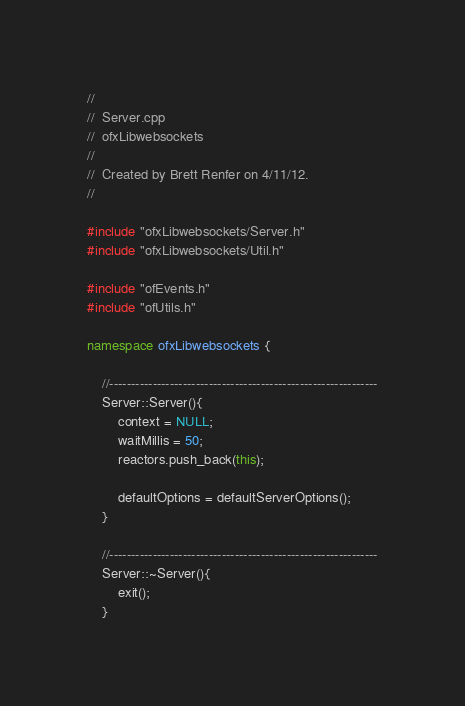Convert code to text. <code><loc_0><loc_0><loc_500><loc_500><_C++_>//
//  Server.cpp
//  ofxLibwebsockets
//
//  Created by Brett Renfer on 4/11/12.
//

#include "ofxLibwebsockets/Server.h"
#include "ofxLibwebsockets/Util.h"

#include "ofEvents.h"
#include "ofUtils.h"

namespace ofxLibwebsockets {

    //--------------------------------------------------------------
    Server::Server(){
        context = NULL;
        waitMillis = 50;
        reactors.push_back(this);
        
        defaultOptions = defaultServerOptions();
    }
    
    //--------------------------------------------------------------
    Server::~Server(){
        exit();
    }
</code> 